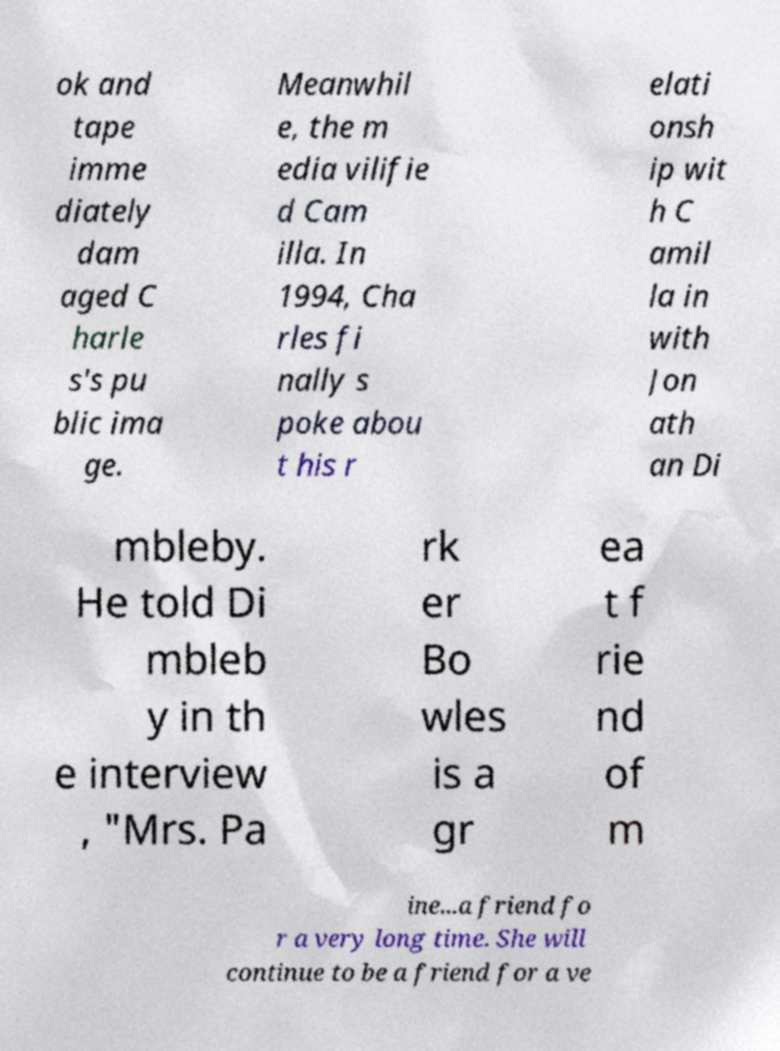Please identify and transcribe the text found in this image. ok and tape imme diately dam aged C harle s's pu blic ima ge. Meanwhil e, the m edia vilifie d Cam illa. In 1994, Cha rles fi nally s poke abou t his r elati onsh ip wit h C amil la in with Jon ath an Di mbleby. He told Di mbleb y in th e interview , "Mrs. Pa rk er Bo wles is a gr ea t f rie nd of m ine...a friend fo r a very long time. She will continue to be a friend for a ve 